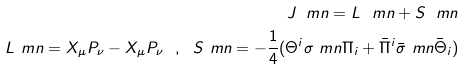Convert formula to latex. <formula><loc_0><loc_0><loc_500><loc_500>J _ { \ } m n = L _ { \ } m n + S _ { \ } m n \\ L _ { \ } m n = X _ { \mu } P _ { \nu } - X _ { \mu } P _ { \nu } \ \ , \ \ S _ { \ } m n = - \frac { 1 } { 4 } ( \Theta ^ { i } \sigma _ { \ } m n \Pi _ { i } + \bar { \Pi } ^ { i } \bar { \sigma } _ { \ } m n \bar { \Theta } _ { i } )</formula> 